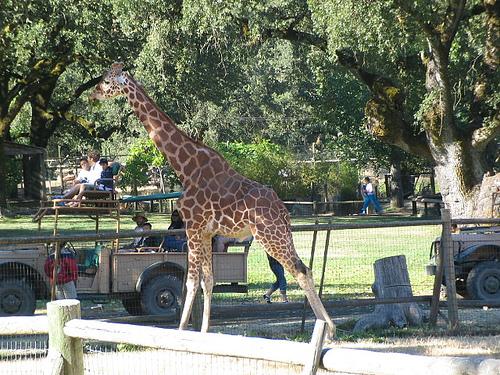How many vehicles are in this photo?
Be succinct. 2. What are the people sitting on over the truck?
Answer briefly. Chairs. Why is the SUV there?
Give a very brief answer. Tour. 